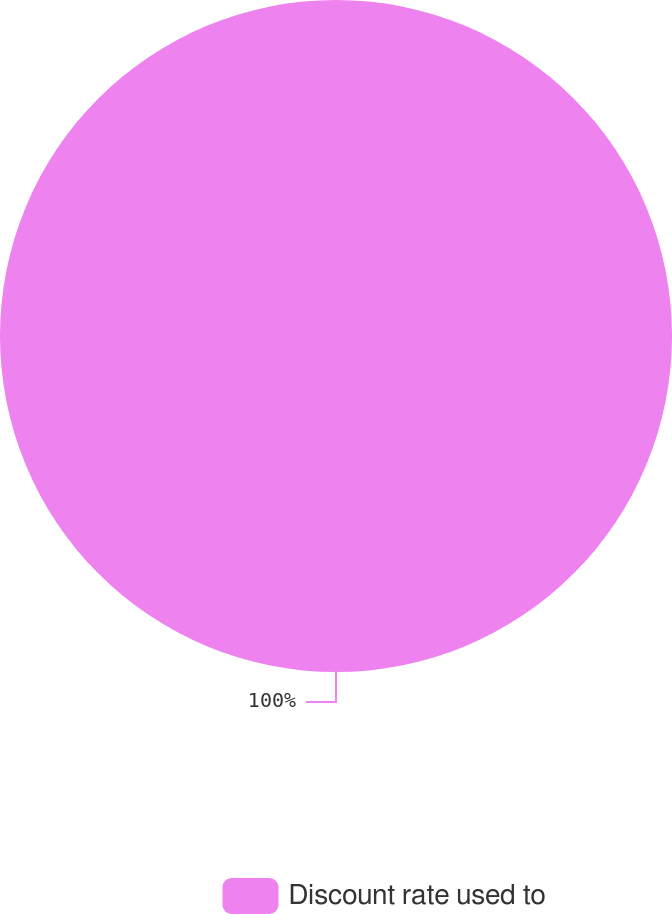Convert chart to OTSL. <chart><loc_0><loc_0><loc_500><loc_500><pie_chart><fcel>Discount rate used to<nl><fcel>100.0%<nl></chart> 